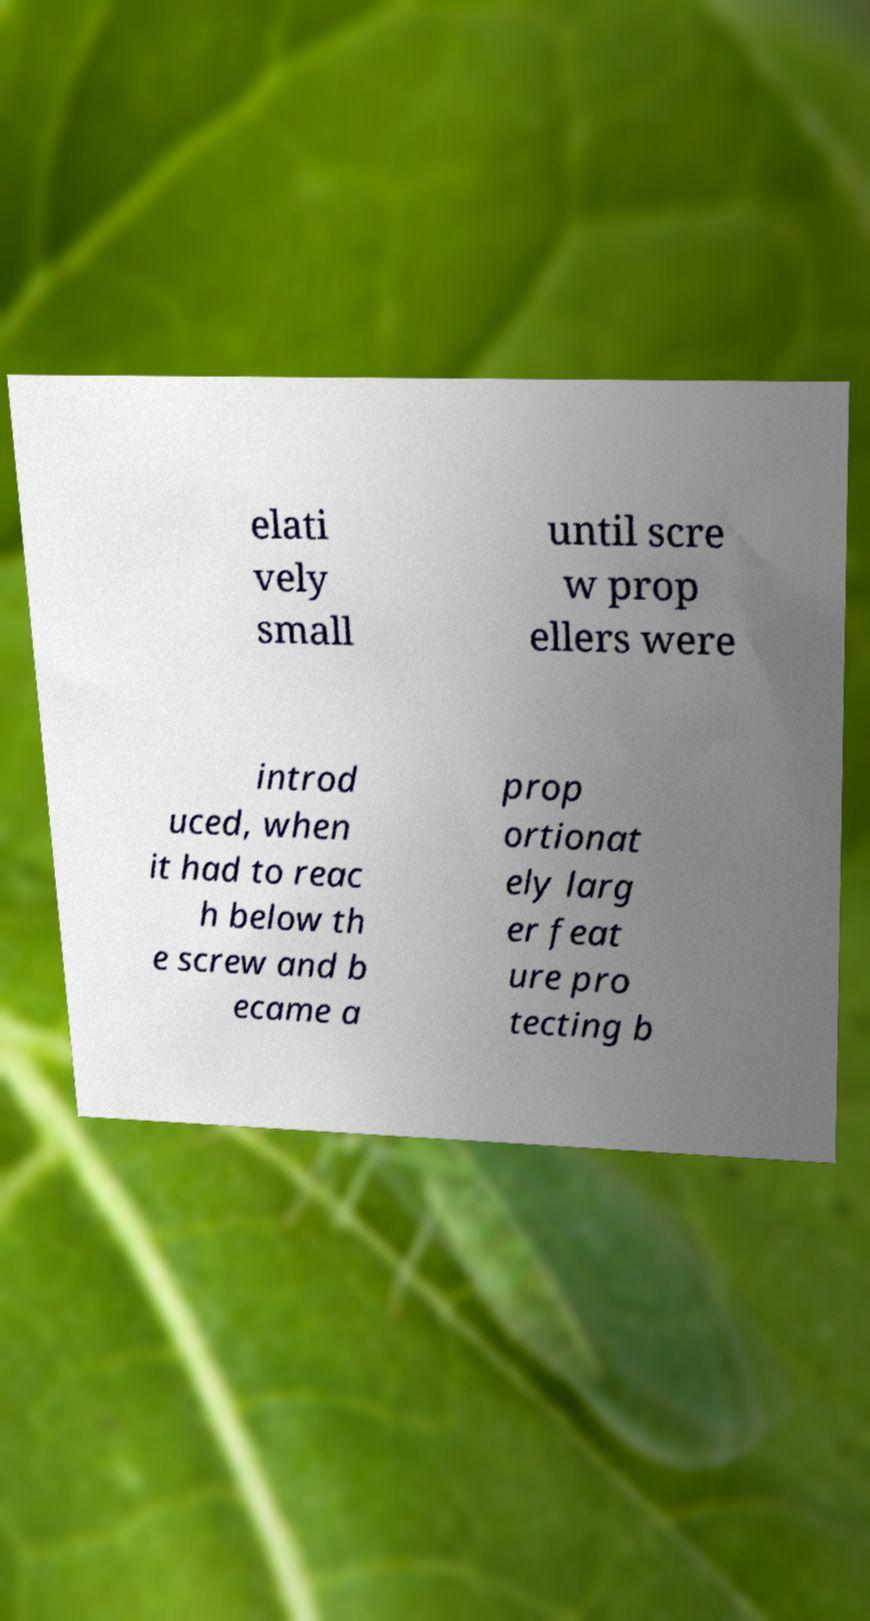What messages or text are displayed in this image? I need them in a readable, typed format. elati vely small until scre w prop ellers were introd uced, when it had to reac h below th e screw and b ecame a prop ortionat ely larg er feat ure pro tecting b 